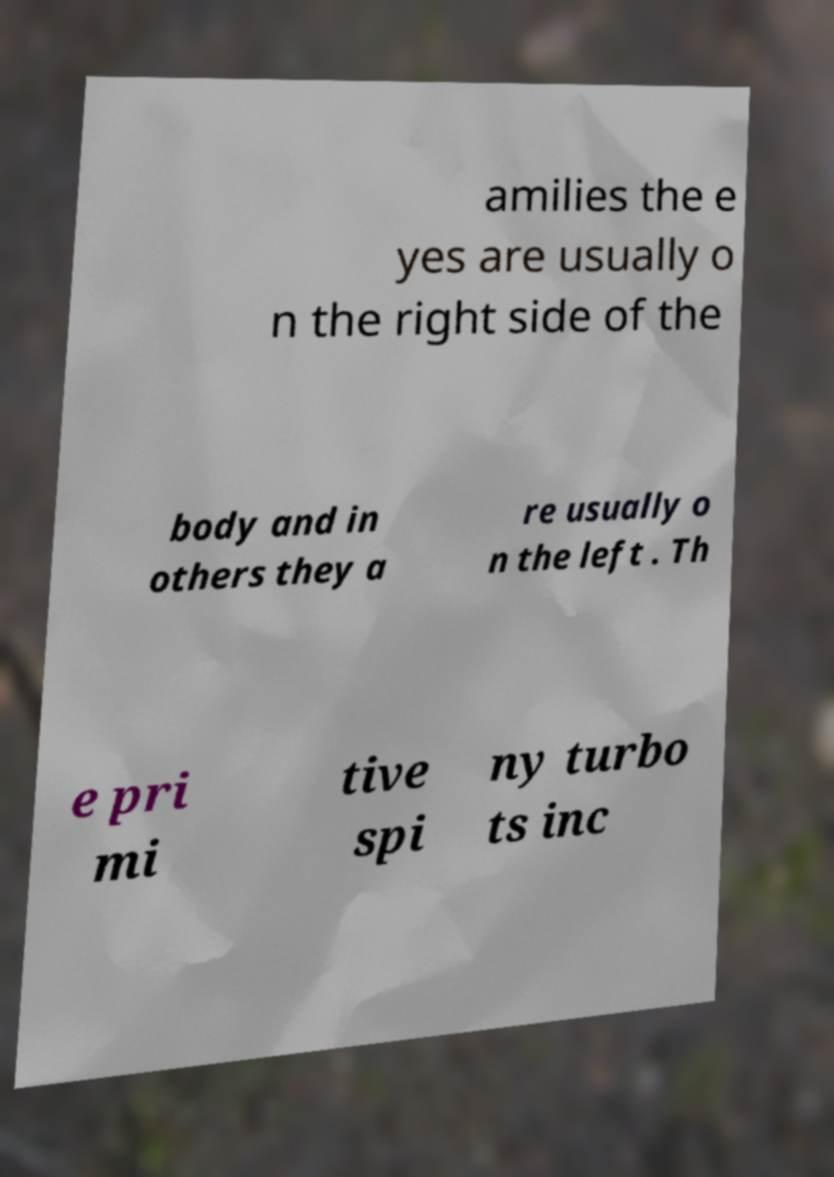Could you assist in decoding the text presented in this image and type it out clearly? amilies the e yes are usually o n the right side of the body and in others they a re usually o n the left . Th e pri mi tive spi ny turbo ts inc 